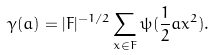<formula> <loc_0><loc_0><loc_500><loc_500>\gamma ( a ) = | F | ^ { - 1 / 2 } \sum _ { x \in F } \psi ( \frac { 1 } { 2 } a x ^ { 2 } ) .</formula> 